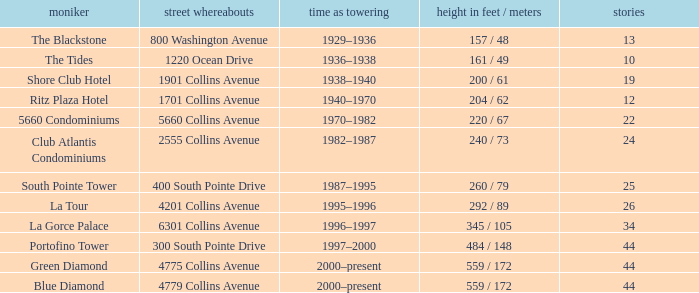How many floors does the Blue Diamond have? 44.0. 